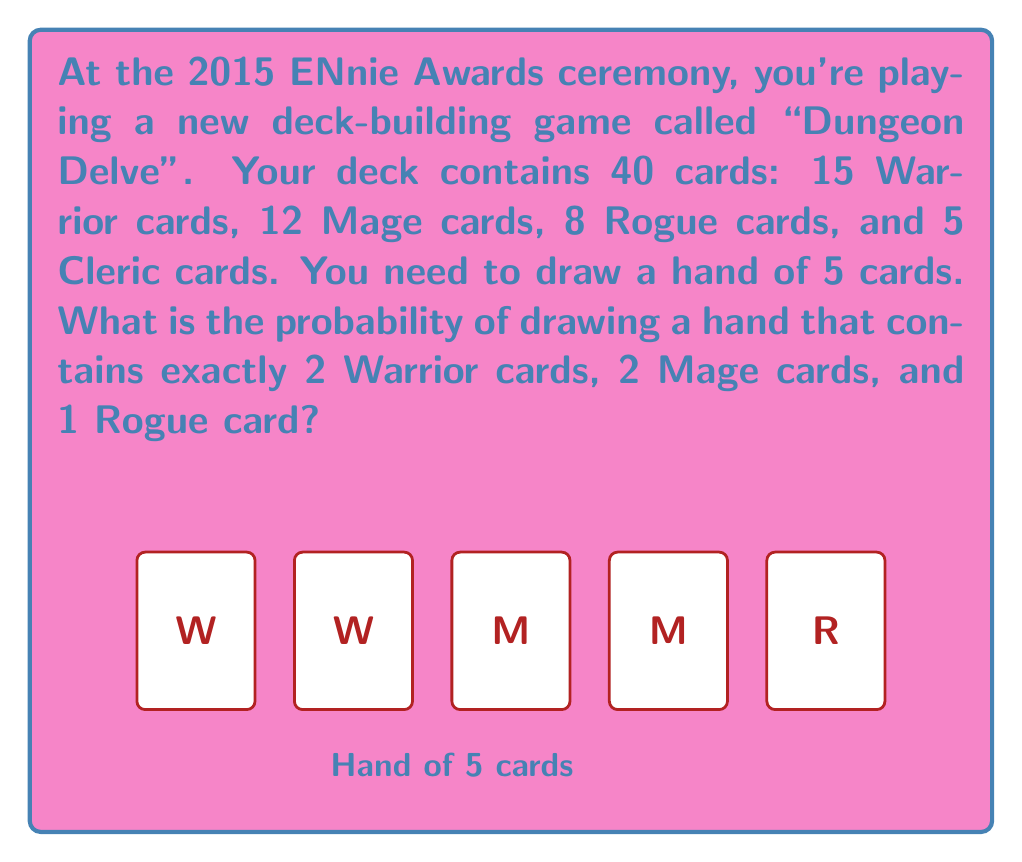Can you solve this math problem? Let's approach this step-by-step using the hypergeometric distribution:

1) We need to calculate the probability of drawing:
   - 2 Warrior cards out of 15
   - 2 Mage cards out of 12
   - 1 Rogue card out of 8
   - 0 Cleric cards out of 5

2) The total number of ways to choose 5 cards from 40 is $\binom{40}{5}$.

3) The number of ways to choose the specific combination we want is:
   $\binom{15}{2} \cdot \binom{12}{2} \cdot \binom{8}{1} \cdot \binom{5}{0}$

4) Therefore, the probability is:

   $$P = \frac{\binom{15}{2} \cdot \binom{12}{2} \cdot \binom{8}{1} \cdot \binom{5}{0}}{\binom{40}{5}}$$

5) Let's calculate each part:
   $\binom{15}{2} = 105$
   $\binom{12}{2} = 66$
   $\binom{8}{1} = 8$
   $\binom{5}{0} = 1$
   $\binom{40}{5} = 658,008$

6) Substituting these values:

   $$P = \frac{105 \cdot 66 \cdot 8 \cdot 1}{658,008} = \frac{55,440}{658,008} \approx 0.0842$$

7) Converting to a percentage:
   $0.0842 \cdot 100\% = 8.42\%$
Answer: 8.42% 